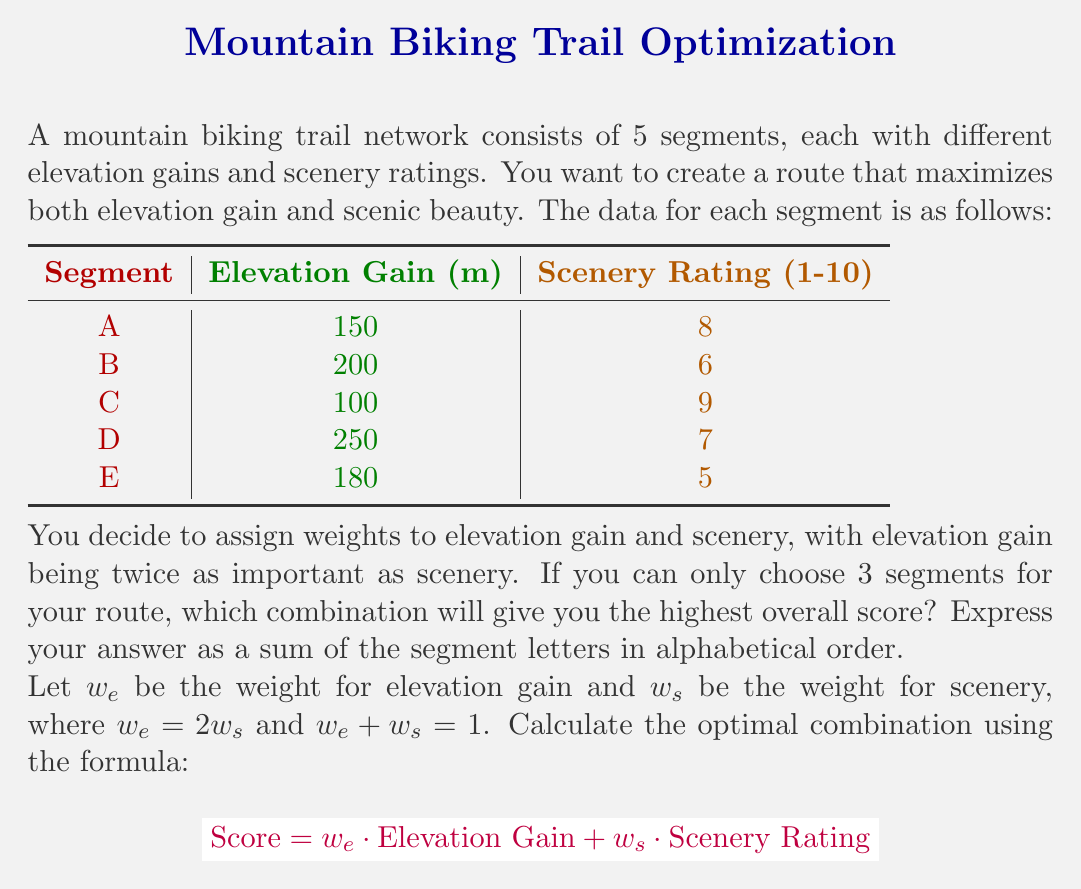Could you help me with this problem? To solve this problem, we need to follow these steps:

1. Calculate the weights:
   Since $w_e = 2w_s$ and $w_e + w_s = 1$, we can solve for $w_s$:
   $2w_s + w_s = 1$
   $3w_s = 1$
   $w_s = \frac{1}{3}$
   Therefore, $w_e = \frac{2}{3}$

2. Calculate the score for each segment:
   $\text{Score} = \frac{2}{3} \cdot \text{Elevation Gain} + \frac{1}{3} \cdot \text{Scenery Rating}$

   A: $\frac{2}{3} \cdot 150 + \frac{1}{3} \cdot 8 = 100 + 2.67 = 102.67$
   B: $\frac{2}{3} \cdot 200 + \frac{1}{3} \cdot 6 = 133.33 + 2 = 135.33$
   C: $\frac{2}{3} \cdot 100 + \frac{1}{3} \cdot 9 = 66.67 + 3 = 69.67$
   D: $\frac{2}{3} \cdot 250 + \frac{1}{3} \cdot 7 = 166.67 + 2.33 = 169$
   E: $\frac{2}{3} \cdot 180 + \frac{1}{3} \cdot 5 = 120 + 1.67 = 121.67$

3. Find the top 3 scoring segments:
   The top 3 scores are D (169), B (135.33), and A (102.67).

Therefore, the optimal combination of 3 segments is A, B, and D.
Answer: ABD 